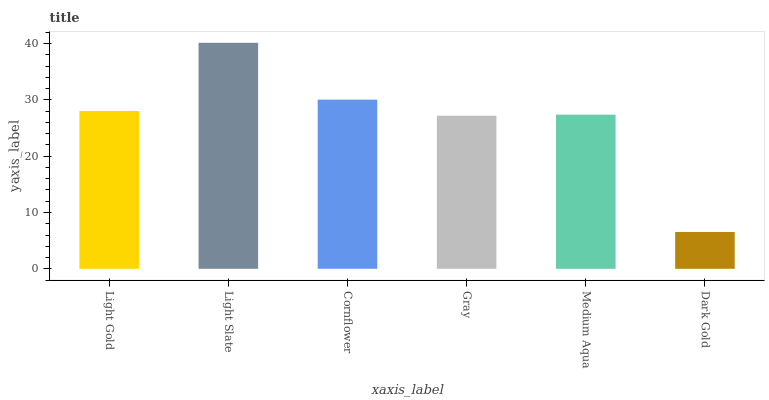Is Dark Gold the minimum?
Answer yes or no. Yes. Is Light Slate the maximum?
Answer yes or no. Yes. Is Cornflower the minimum?
Answer yes or no. No. Is Cornflower the maximum?
Answer yes or no. No. Is Light Slate greater than Cornflower?
Answer yes or no. Yes. Is Cornflower less than Light Slate?
Answer yes or no. Yes. Is Cornflower greater than Light Slate?
Answer yes or no. No. Is Light Slate less than Cornflower?
Answer yes or no. No. Is Light Gold the high median?
Answer yes or no. Yes. Is Medium Aqua the low median?
Answer yes or no. Yes. Is Cornflower the high median?
Answer yes or no. No. Is Dark Gold the low median?
Answer yes or no. No. 